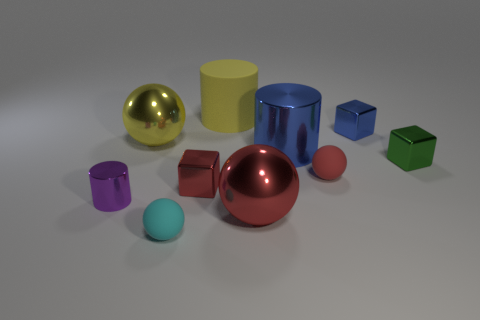Subtract all cylinders. How many objects are left? 7 Add 6 small rubber spheres. How many small rubber spheres exist? 8 Subtract 0 red cylinders. How many objects are left? 10 Subtract all red shiny cubes. Subtract all tiny brown objects. How many objects are left? 9 Add 5 large things. How many large things are left? 9 